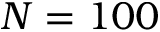<formula> <loc_0><loc_0><loc_500><loc_500>N = 1 0 0</formula> 